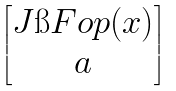Convert formula to latex. <formula><loc_0><loc_0><loc_500><loc_500>\begin{bmatrix} J \i F o p ( x ) \\ a \end{bmatrix}</formula> 